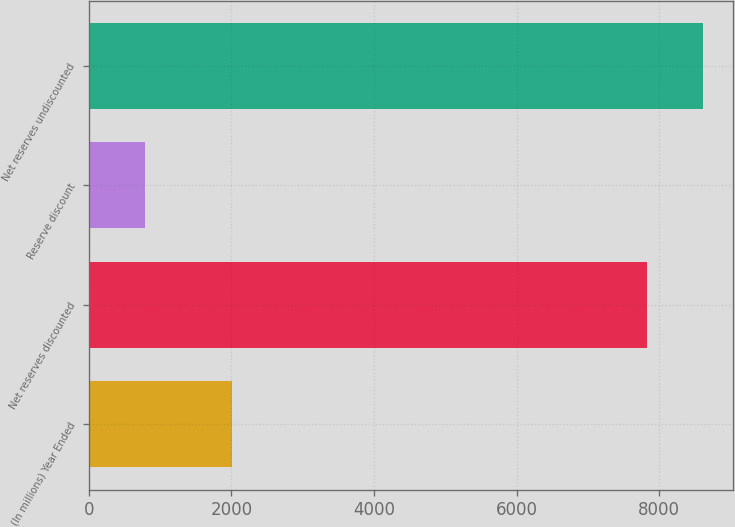Convert chart. <chart><loc_0><loc_0><loc_500><loc_500><bar_chart><fcel>(In millions) Year Ended<fcel>Net reserves discounted<fcel>Reserve discount<fcel>Net reserves undiscounted<nl><fcel>2007<fcel>7823<fcel>788<fcel>8611<nl></chart> 